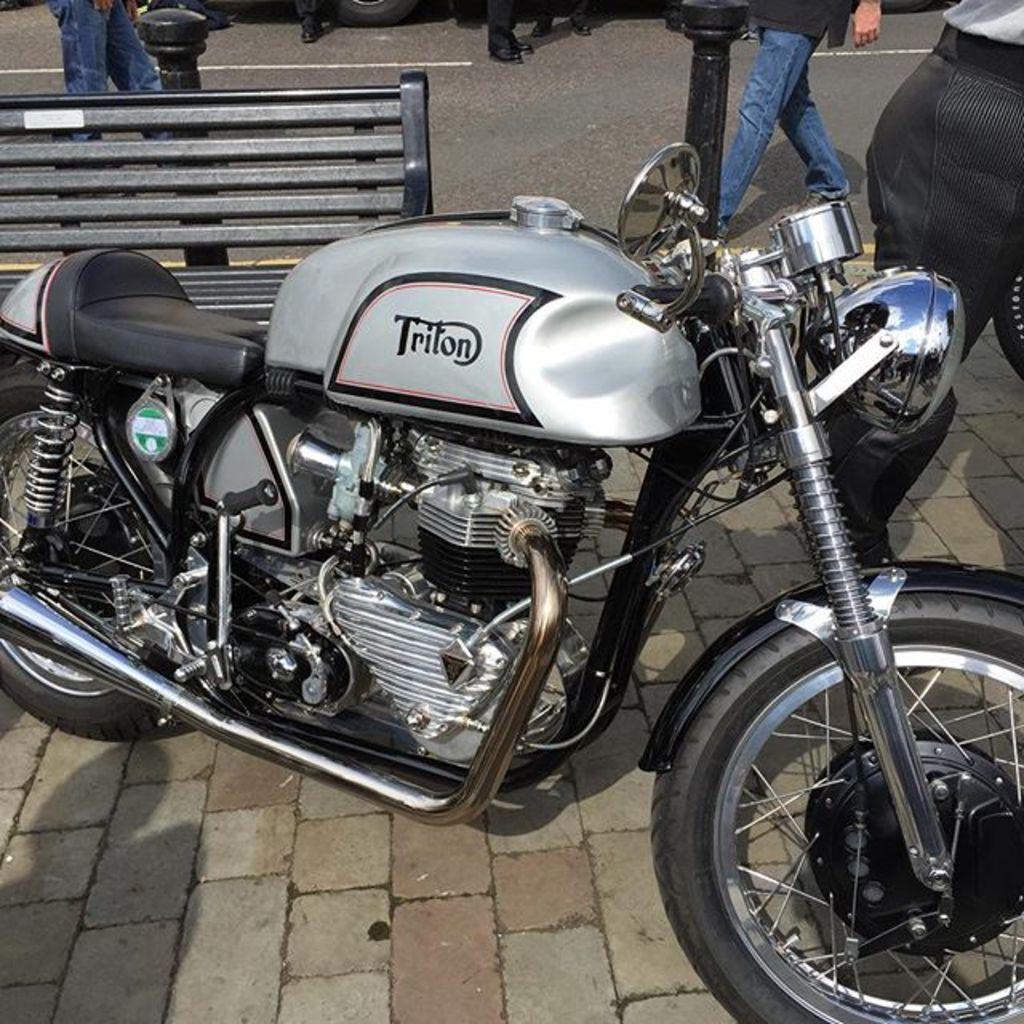Could you give a brief overview of what you see in this image? In this image there is a bike on the pavement. Left side there is a fence. There are poles on the pavement. Right side there is a person walking on the pavement. There are people walking on the road. Top of the image there is a vehicle on the road. 